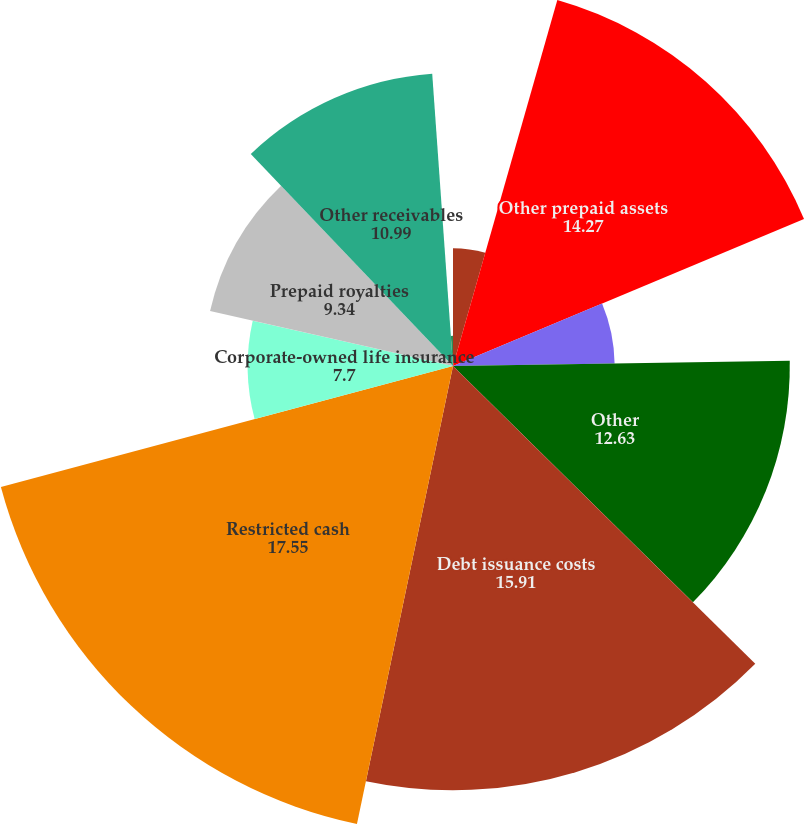<chart> <loc_0><loc_0><loc_500><loc_500><pie_chart><fcel>Prepaid income and mining<fcel>Other prepaid assets<fcel>Notes receivable<fcel>Other<fcel>Debt issuance costs<fcel>Restricted cash<fcel>Corporate-owned life insurance<fcel>Prepaid royalties<fcel>Other receivables<fcel>Prepaid maintenance costs<nl><fcel>4.42%<fcel>14.27%<fcel>6.06%<fcel>12.63%<fcel>15.91%<fcel>17.55%<fcel>7.7%<fcel>9.34%<fcel>10.99%<fcel>1.13%<nl></chart> 